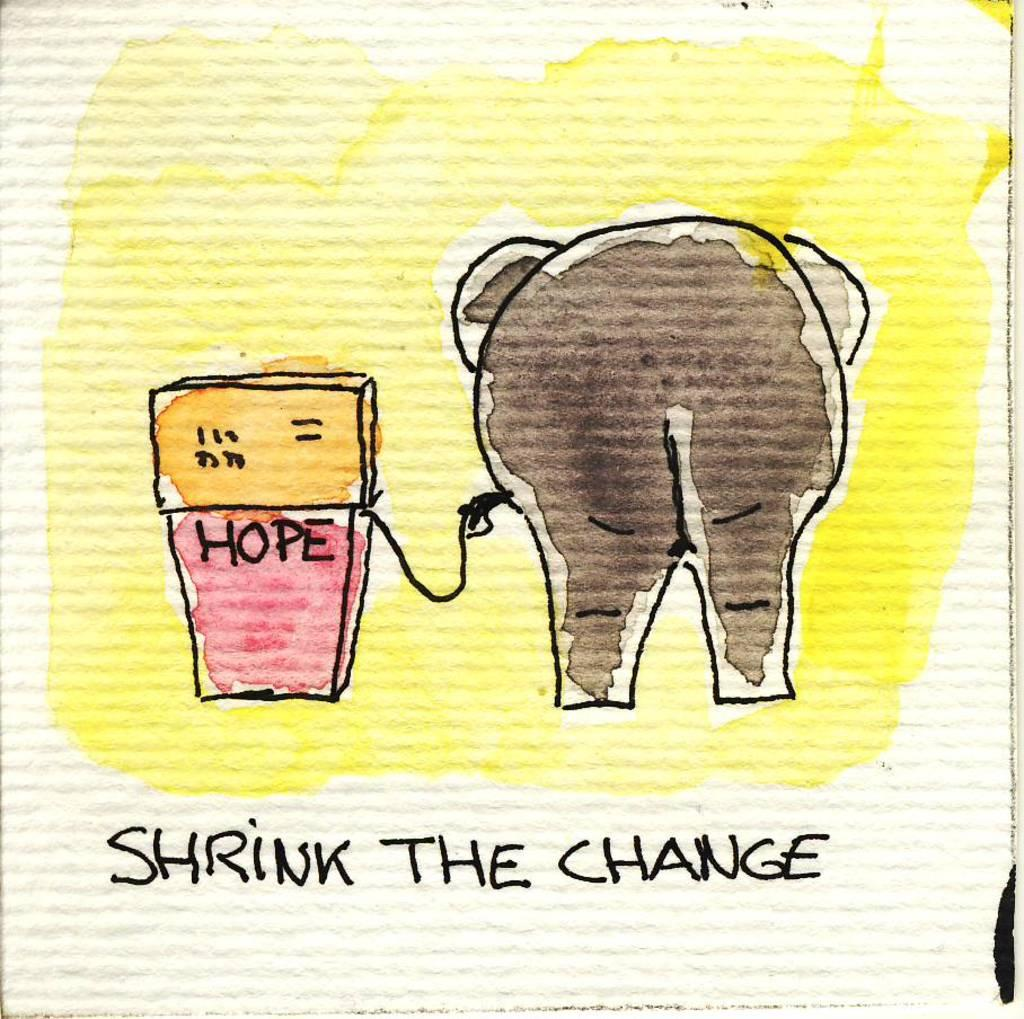What type of visual is the image? The image is a poster. What object is depicted on the poster? There is a box on the poster. Are there any words or phrases on the poster? Yes, there is text on the poster. Can you describe the woman's reaction to the destruction caused by the tiger in the image? There is no woman, destruction, or tiger present in the image; it only features a poster with a box and text. 